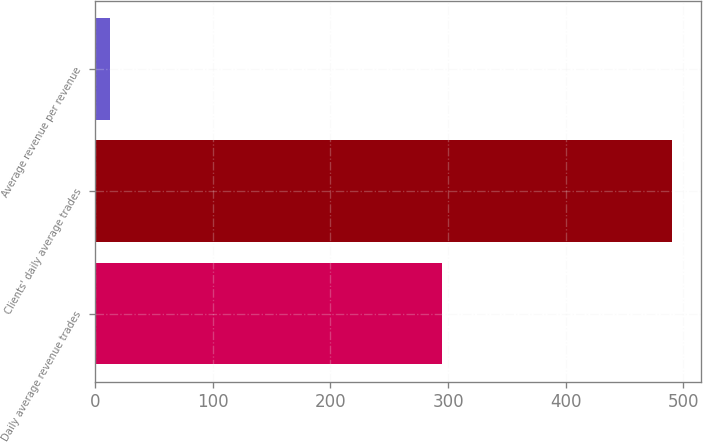Convert chart to OTSL. <chart><loc_0><loc_0><loc_500><loc_500><bar_chart><fcel>Daily average revenue trades<fcel>Clients' daily average trades<fcel>Average revenue per revenue<nl><fcel>295<fcel>490.5<fcel>12.31<nl></chart> 